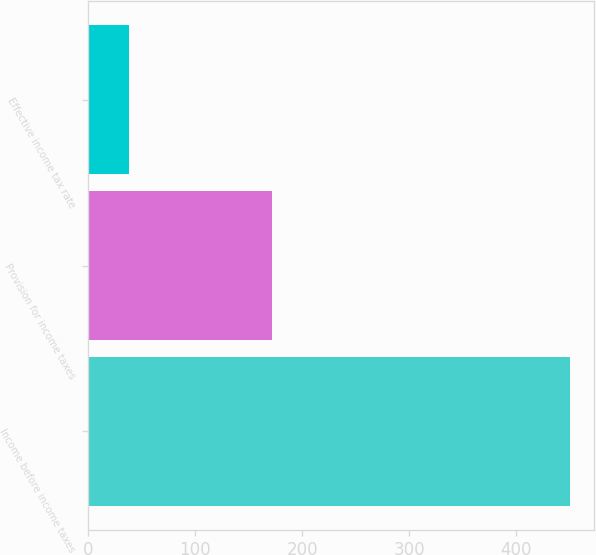Convert chart to OTSL. <chart><loc_0><loc_0><loc_500><loc_500><bar_chart><fcel>Income before income taxes<fcel>Provision for income taxes<fcel>Effective income tax rate<nl><fcel>450.6<fcel>171.3<fcel>38<nl></chart> 